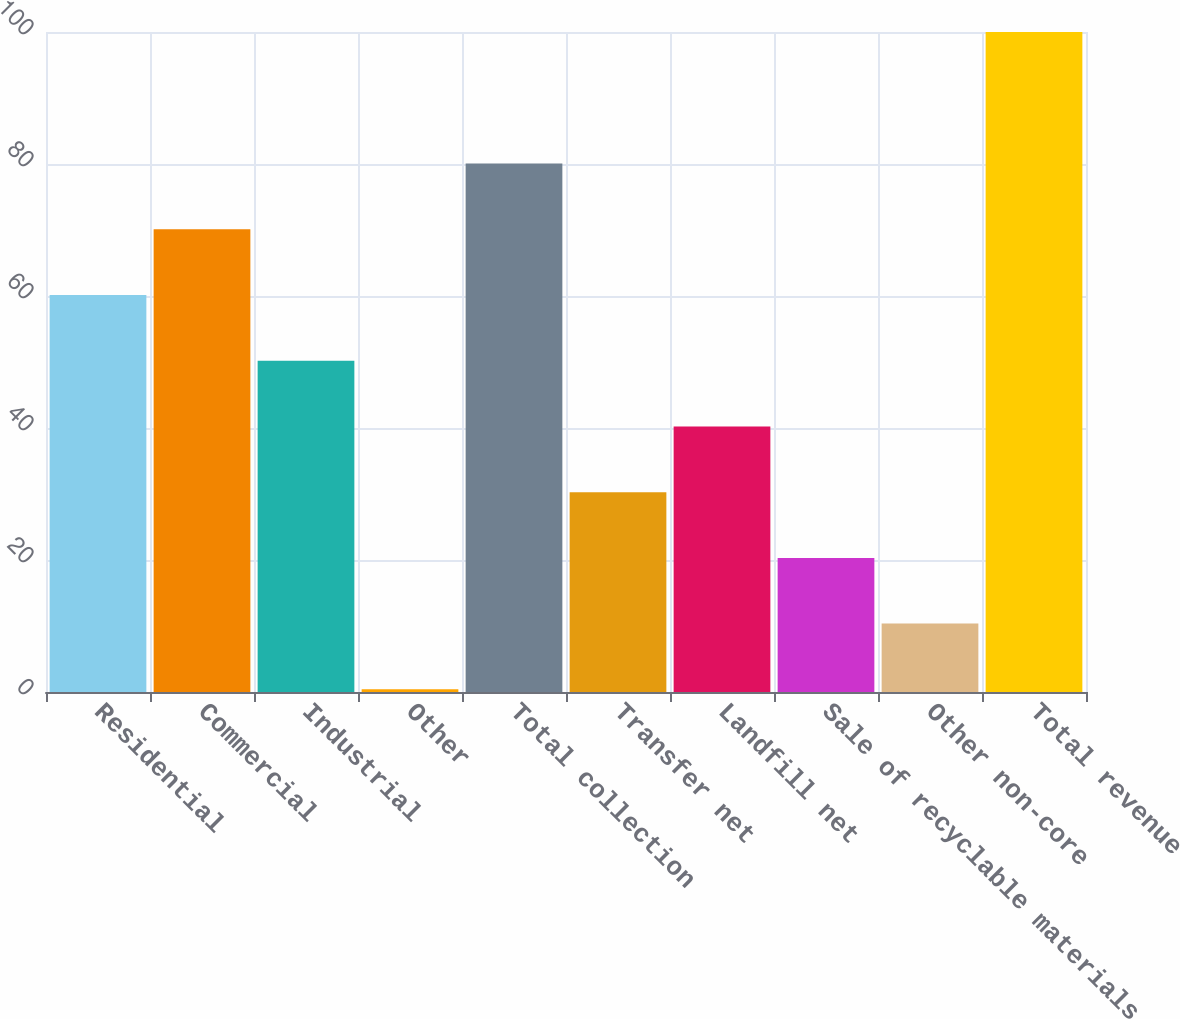Convert chart. <chart><loc_0><loc_0><loc_500><loc_500><bar_chart><fcel>Residential<fcel>Commercial<fcel>Industrial<fcel>Other<fcel>Total collection<fcel>Transfer net<fcel>Landfill net<fcel>Sale of recyclable materials<fcel>Other non-core<fcel>Total revenue<nl><fcel>60.16<fcel>70.12<fcel>50.2<fcel>0.4<fcel>80.08<fcel>30.28<fcel>40.24<fcel>20.32<fcel>10.36<fcel>100<nl></chart> 